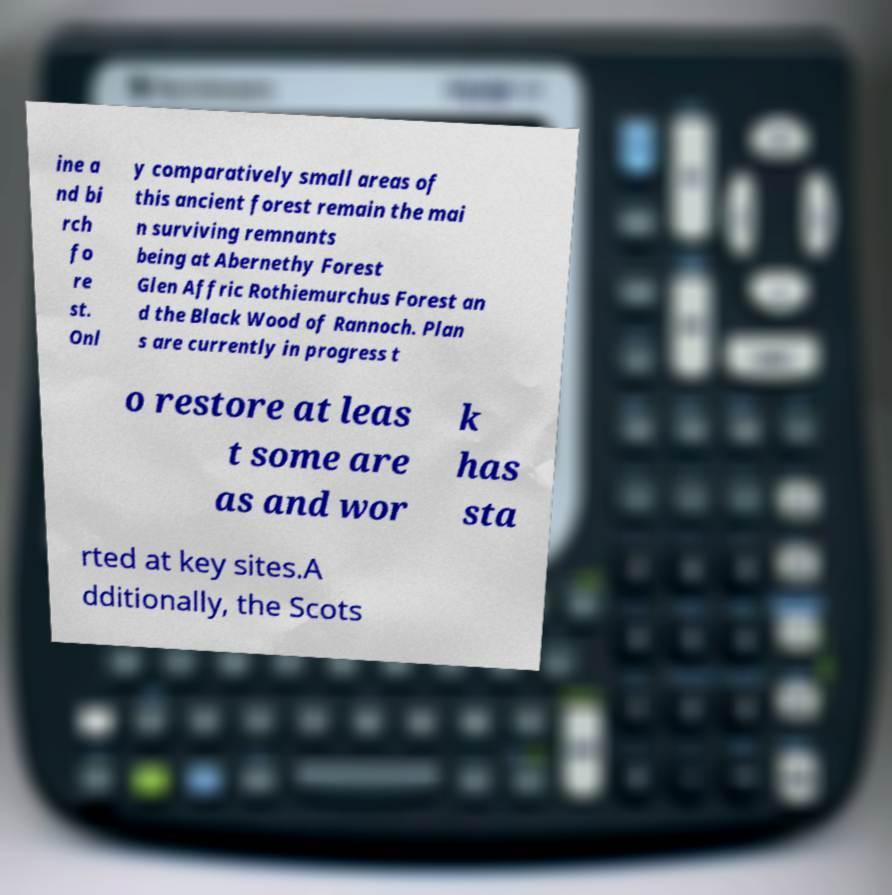Please identify and transcribe the text found in this image. ine a nd bi rch fo re st. Onl y comparatively small areas of this ancient forest remain the mai n surviving remnants being at Abernethy Forest Glen Affric Rothiemurchus Forest an d the Black Wood of Rannoch. Plan s are currently in progress t o restore at leas t some are as and wor k has sta rted at key sites.A dditionally, the Scots 